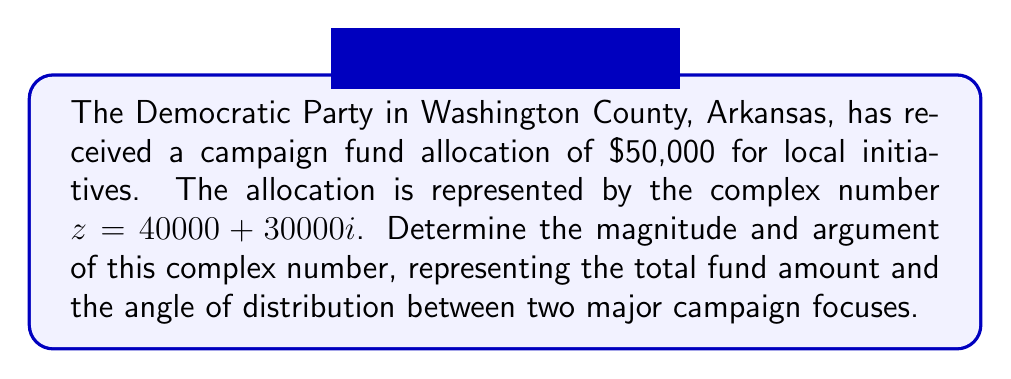Can you answer this question? To find the magnitude and argument of the complex number $z = 40000 + 30000i$, we'll follow these steps:

1. Magnitude (r):
   The magnitude is calculated using the formula $r = \sqrt{a^2 + b^2}$, where $a$ is the real part and $b$ is the imaginary part.
   
   $r = \sqrt{40000^2 + 30000^2}$
   $r = \sqrt{1600000000 + 900000000}$
   $r = \sqrt{2500000000}$
   $r = 50000$

2. Argument (θ):
   The argument is calculated using the formula $\theta = \tan^{-1}(\frac{b}{a})$, where $a$ is the real part and $b$ is the imaginary part.
   
   $\theta = \tan^{-1}(\frac{30000}{40000})$
   $\theta = \tan^{-1}(0.75)$
   $\theta \approx 0.6435$ radians

3. Convert radians to degrees:
   $\theta ≈ 0.6435 \times \frac{180}{\pi} \approx 36.87°$

The magnitude $50000 represents the total campaign fund allocation of $50,000.
The argument $36.87°$ represents the angle of distribution between two major campaign focuses.
Answer: Magnitude: $50000$, Argument: $36.87°$ 